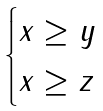Convert formula to latex. <formula><loc_0><loc_0><loc_500><loc_500>\begin{cases} x \geq y \\ x \geq z \end{cases}</formula> 